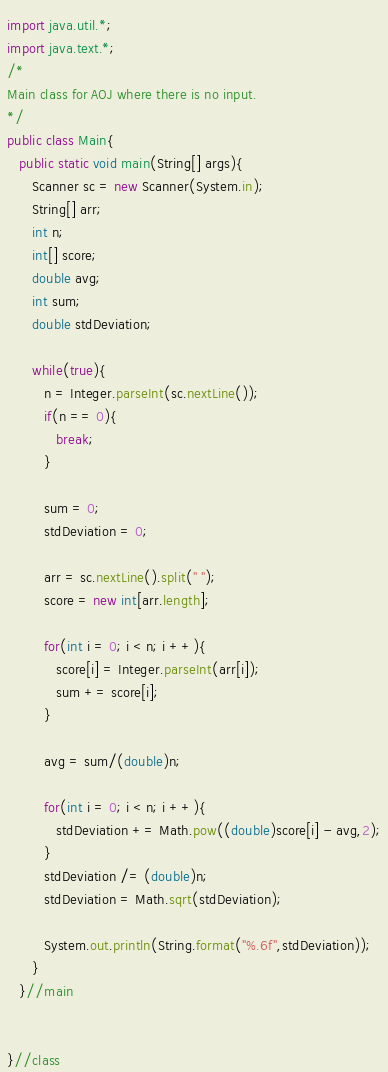Convert code to text. <code><loc_0><loc_0><loc_500><loc_500><_Java_>import java.util.*;
import java.text.*;
/*
Main class for AOJ where there is no input.
*/
public class Main{
   public static void main(String[] args){
      Scanner sc = new Scanner(System.in);
      String[] arr;
      int n;
      int[] score;
      double avg;
      int sum;
      double stdDeviation;
      
      while(true){
         n = Integer.parseInt(sc.nextLine());
         if(n == 0){
            break;
         }
         
         sum = 0;
         stdDeviation = 0;
         
         arr = sc.nextLine().split(" ");
         score = new int[arr.length];
         
         for(int i = 0; i < n; i ++){
            score[i] = Integer.parseInt(arr[i]);
            sum += score[i];
         }
         
         avg = sum/(double)n;
         
         for(int i = 0; i < n; i ++){
            stdDeviation += Math.pow((double)score[i] - avg,2);
         }
         stdDeviation /= (double)n;
         stdDeviation = Math.sqrt(stdDeviation);
         
         System.out.println(String.format("%.6f",stdDeviation));
      }
   }//main
   
   
}//class</code> 